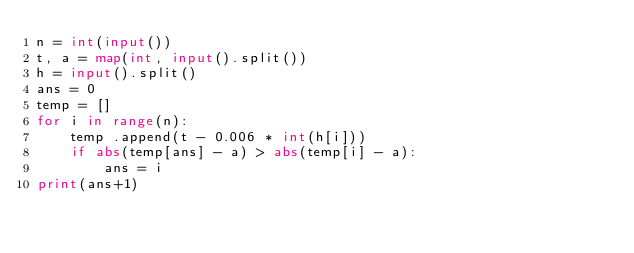<code> <loc_0><loc_0><loc_500><loc_500><_Python_>n = int(input())
t, a = map(int, input().split())
h = input().split()
ans = 0
temp = []
for i in range(n):
    temp .append(t - 0.006 * int(h[i]))
    if abs(temp[ans] - a) > abs(temp[i] - a):
        ans = i
print(ans+1)
</code> 